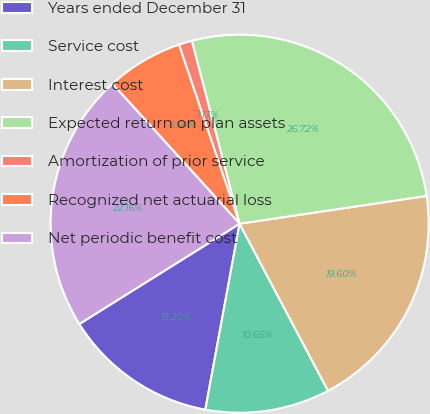<chart> <loc_0><loc_0><loc_500><loc_500><pie_chart><fcel>Years ended December 31<fcel>Service cost<fcel>Interest cost<fcel>Expected return on plan assets<fcel>Amortization of prior service<fcel>Recognized net actuarial loss<fcel>Net periodic benefit cost<nl><fcel>13.2%<fcel>10.65%<fcel>19.6%<fcel>26.72%<fcel>1.13%<fcel>6.54%<fcel>22.16%<nl></chart> 